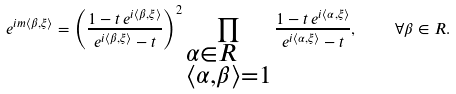Convert formula to latex. <formula><loc_0><loc_0><loc_500><loc_500>e ^ { i m \langle \beta , \xi \rangle } = \left ( \frac { 1 - t \, e ^ { i \langle \beta , \xi \rangle } } { e ^ { i \langle \beta , \xi \rangle } - t } \right ) ^ { 2 } \prod _ { \begin{subarray} { c } \alpha \in R \\ \langle \alpha , \beta \rangle = 1 \end{subarray} } \frac { 1 - t \, e ^ { i \langle \alpha , \xi \rangle } } { e ^ { i \langle \alpha , \xi \rangle } - t } , \quad \forall \beta \in R .</formula> 